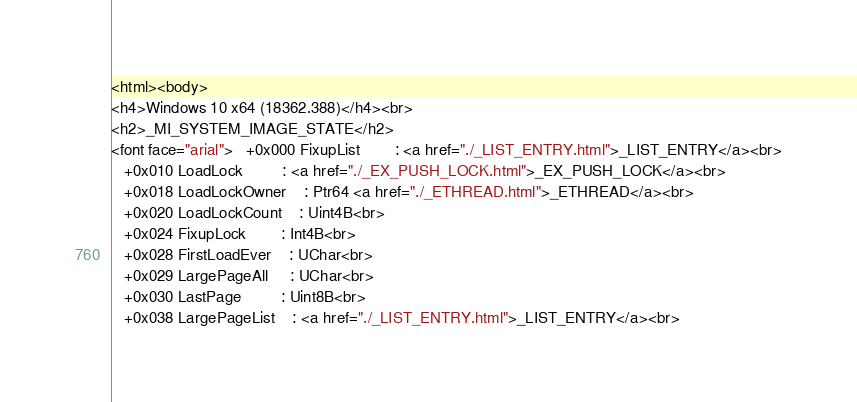<code> <loc_0><loc_0><loc_500><loc_500><_HTML_><html><body>
<h4>Windows 10 x64 (18362.388)</h4><br>
<h2>_MI_SYSTEM_IMAGE_STATE</h2>
<font face="arial">   +0x000 FixupList        : <a href="./_LIST_ENTRY.html">_LIST_ENTRY</a><br>
   +0x010 LoadLock         : <a href="./_EX_PUSH_LOCK.html">_EX_PUSH_LOCK</a><br>
   +0x018 LoadLockOwner    : Ptr64 <a href="./_ETHREAD.html">_ETHREAD</a><br>
   +0x020 LoadLockCount    : Uint4B<br>
   +0x024 FixupLock        : Int4B<br>
   +0x028 FirstLoadEver    : UChar<br>
   +0x029 LargePageAll     : UChar<br>
   +0x030 LastPage         : Uint8B<br>
   +0x038 LargePageList    : <a href="./_LIST_ENTRY.html">_LIST_ENTRY</a><br></code> 